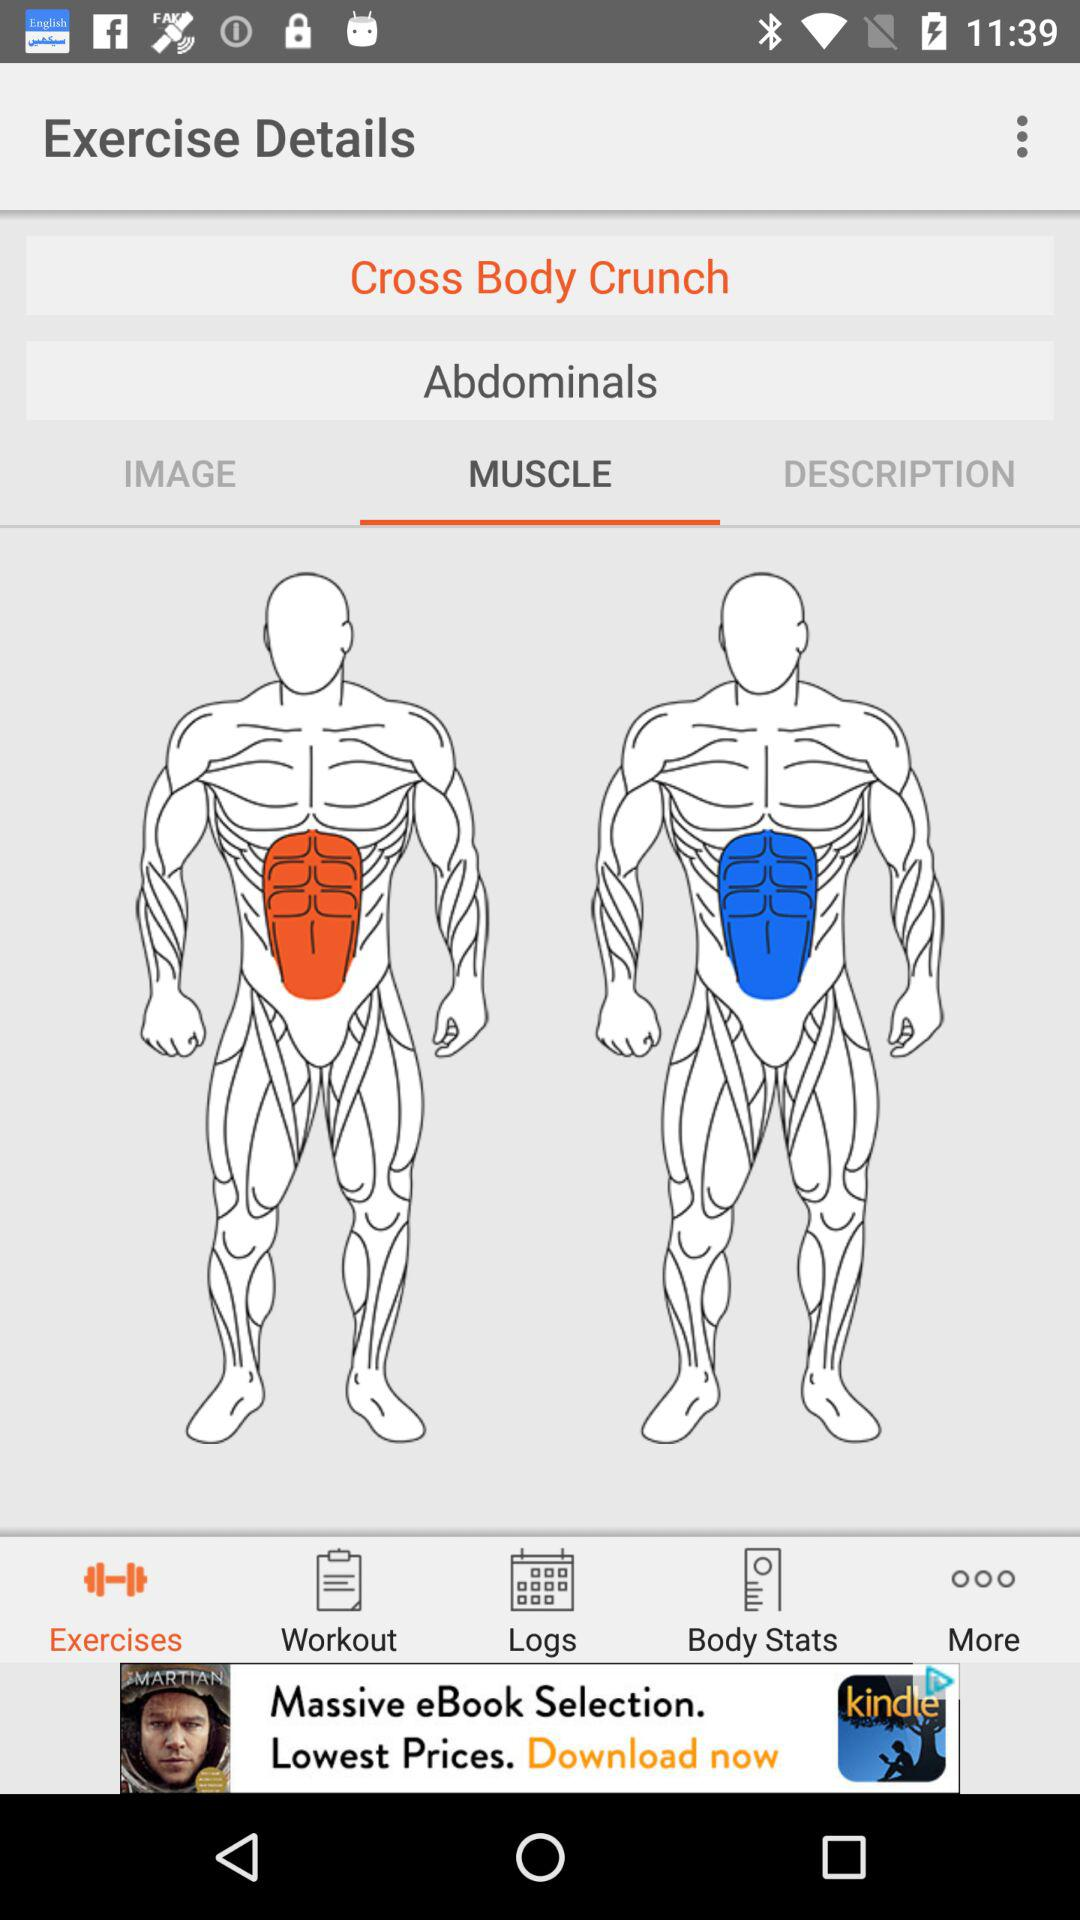What tab has been selected? The tab that has been selected is "MUSCLE". 